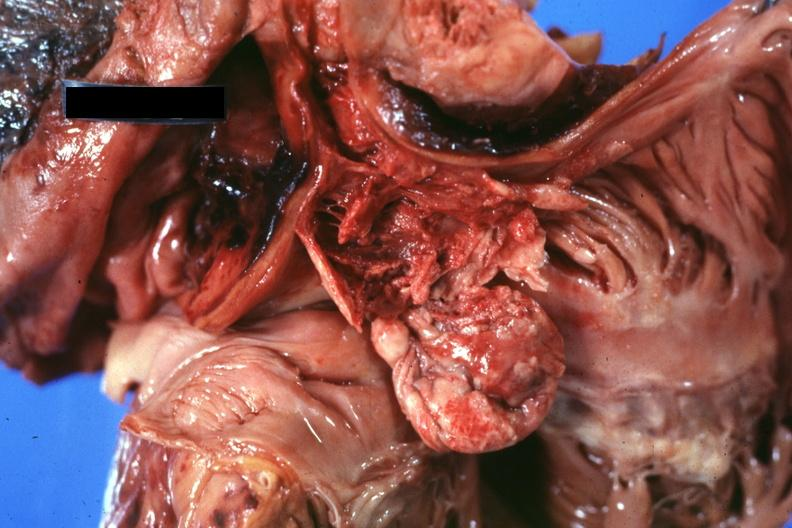what is present?
Answer the question using a single word or phrase. Hematologic 